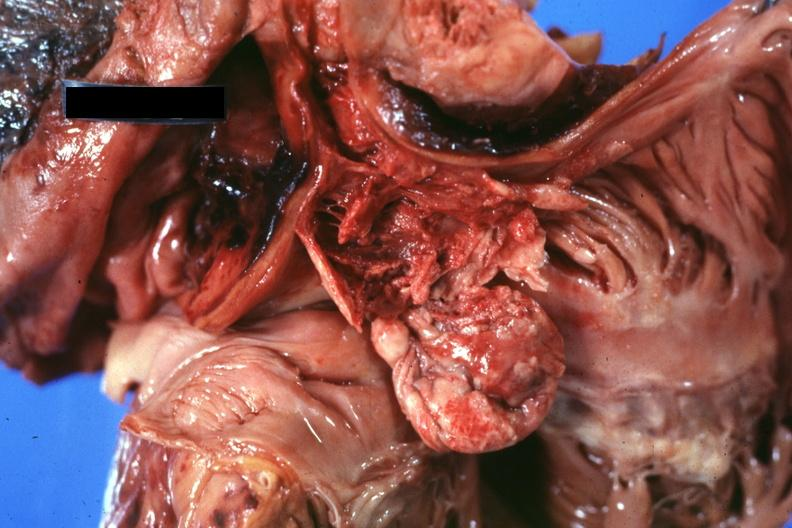what is present?
Answer the question using a single word or phrase. Hematologic 